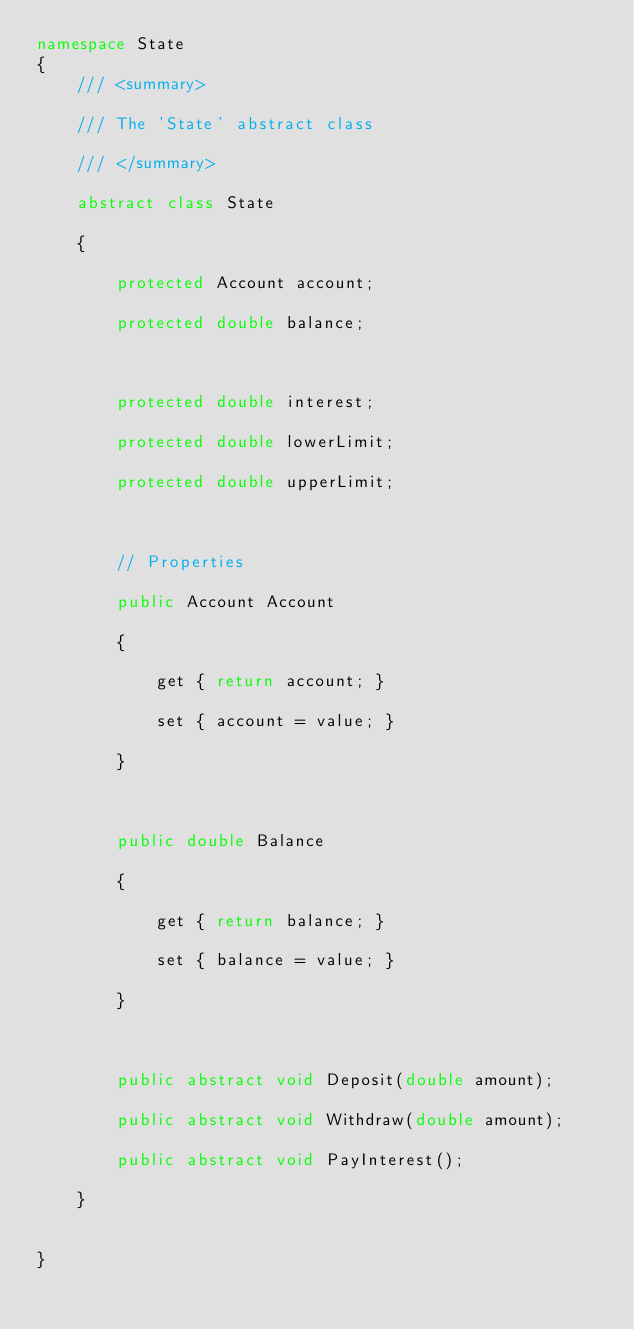<code> <loc_0><loc_0><loc_500><loc_500><_C#_>namespace State
{
    /// <summary>

    /// The 'State' abstract class

    /// </summary>

    abstract class State

    {

        protected Account account;

        protected double balance;

 

        protected double interest;

        protected double lowerLimit;

        protected double upperLimit;

 

        // Properties

        public Account Account

        {

            get { return account; }

            set { account = value; }

        }

 

        public double Balance

        {

            get { return balance; }

            set { balance = value; }

        }

 

        public abstract void Deposit(double amount);

        public abstract void Withdraw(double amount);

        public abstract void PayInterest();

    }


}</code> 